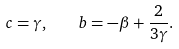Convert formula to latex. <formula><loc_0><loc_0><loc_500><loc_500>c = \gamma , \quad b = - \beta + \frac { 2 } { 3 \gamma } .</formula> 